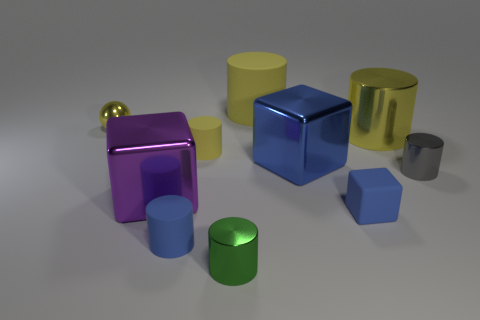Subtract all gray cubes. How many yellow cylinders are left? 3 Subtract all yellow cylinders. How many cylinders are left? 3 Subtract all big metallic cylinders. How many cylinders are left? 5 Subtract all blocks. How many objects are left? 7 Subtract all red cylinders. Subtract all gray blocks. How many cylinders are left? 6 Add 6 large blue matte things. How many large blue matte things exist? 6 Subtract 1 blue cubes. How many objects are left? 9 Subtract all cylinders. Subtract all large green shiny things. How many objects are left? 4 Add 9 blue cylinders. How many blue cylinders are left? 10 